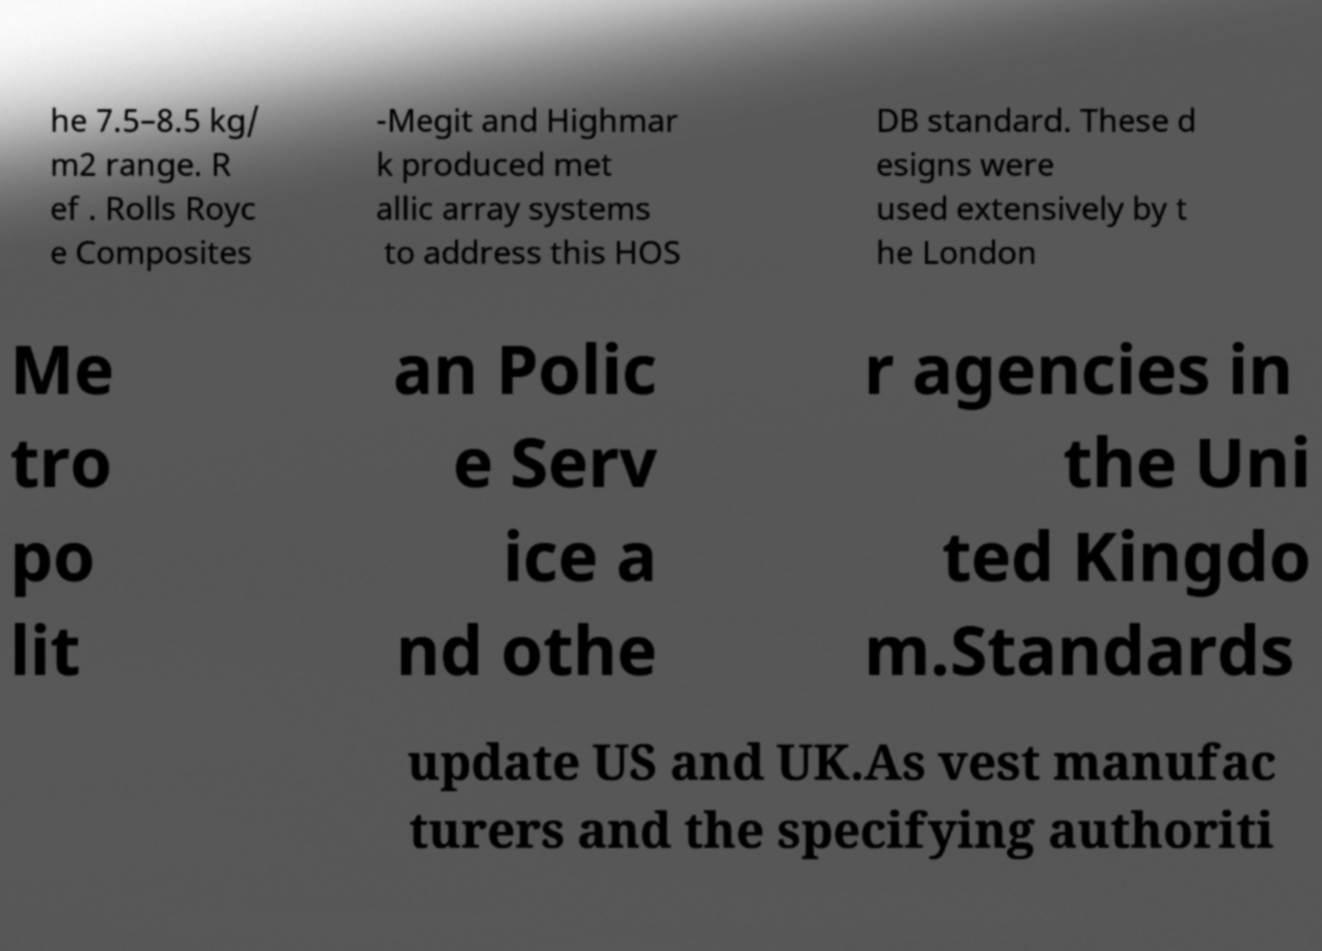There's text embedded in this image that I need extracted. Can you transcribe it verbatim? he 7.5–8.5 kg/ m2 range. R ef . Rolls Royc e Composites -Megit and Highmar k produced met allic array systems to address this HOS DB standard. These d esigns were used extensively by t he London Me tro po lit an Polic e Serv ice a nd othe r agencies in the Uni ted Kingdo m.Standards update US and UK.As vest manufac turers and the specifying authoriti 